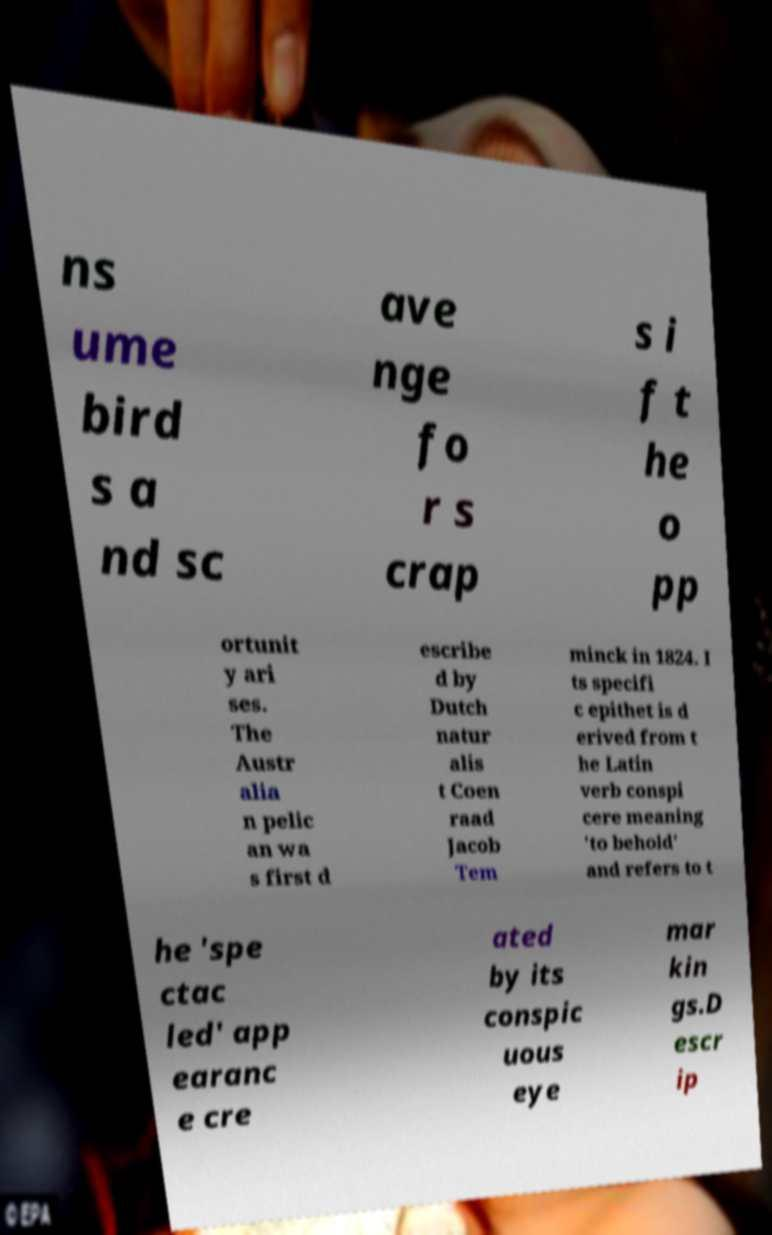Can you accurately transcribe the text from the provided image for me? ns ume bird s a nd sc ave nge fo r s crap s i f t he o pp ortunit y ari ses. The Austr alia n pelic an wa s first d escribe d by Dutch natur alis t Coen raad Jacob Tem minck in 1824. I ts specifi c epithet is d erived from t he Latin verb conspi cere meaning 'to behold' and refers to t he 'spe ctac led' app earanc e cre ated by its conspic uous eye mar kin gs.D escr ip 